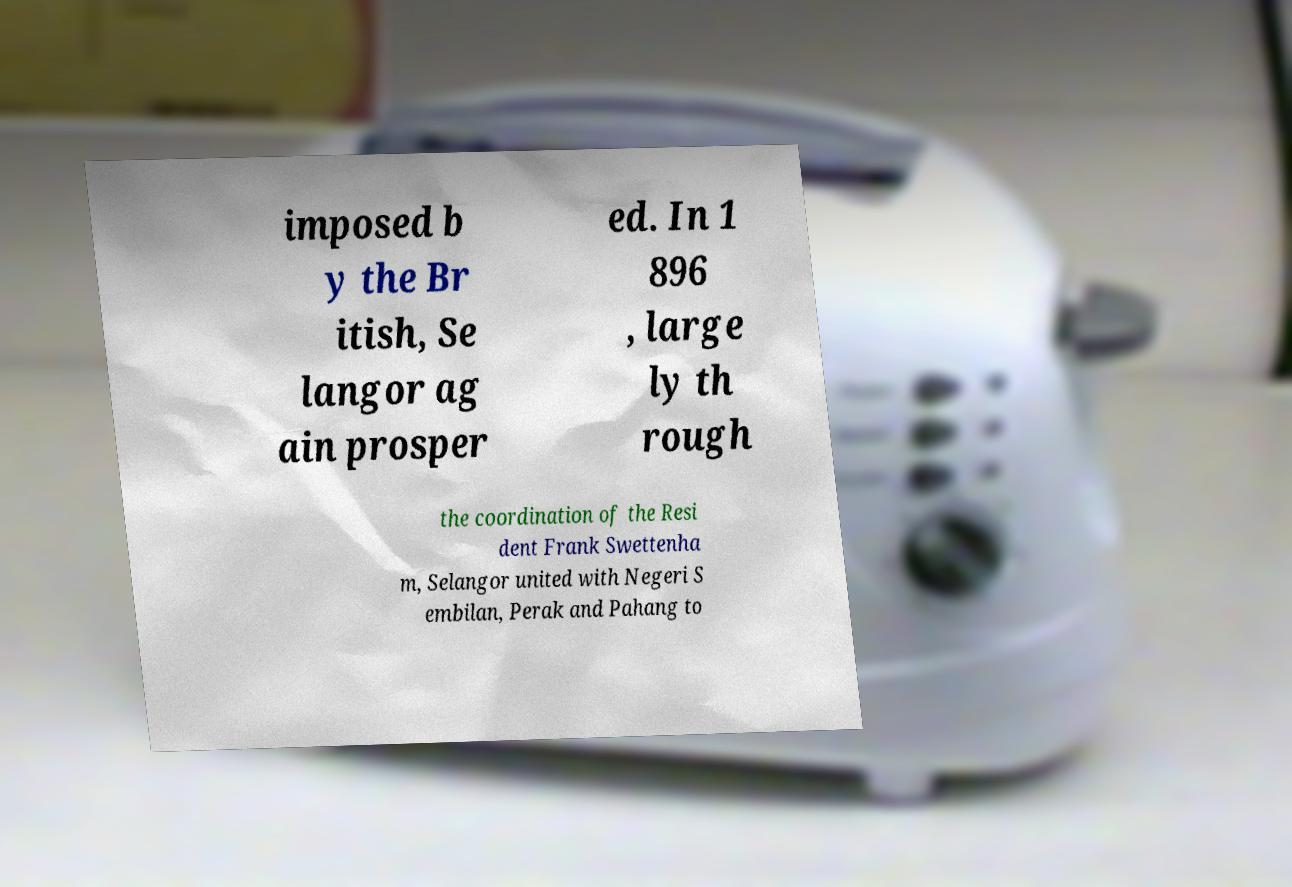What messages or text are displayed in this image? I need them in a readable, typed format. imposed b y the Br itish, Se langor ag ain prosper ed. In 1 896 , large ly th rough the coordination of the Resi dent Frank Swettenha m, Selangor united with Negeri S embilan, Perak and Pahang to 